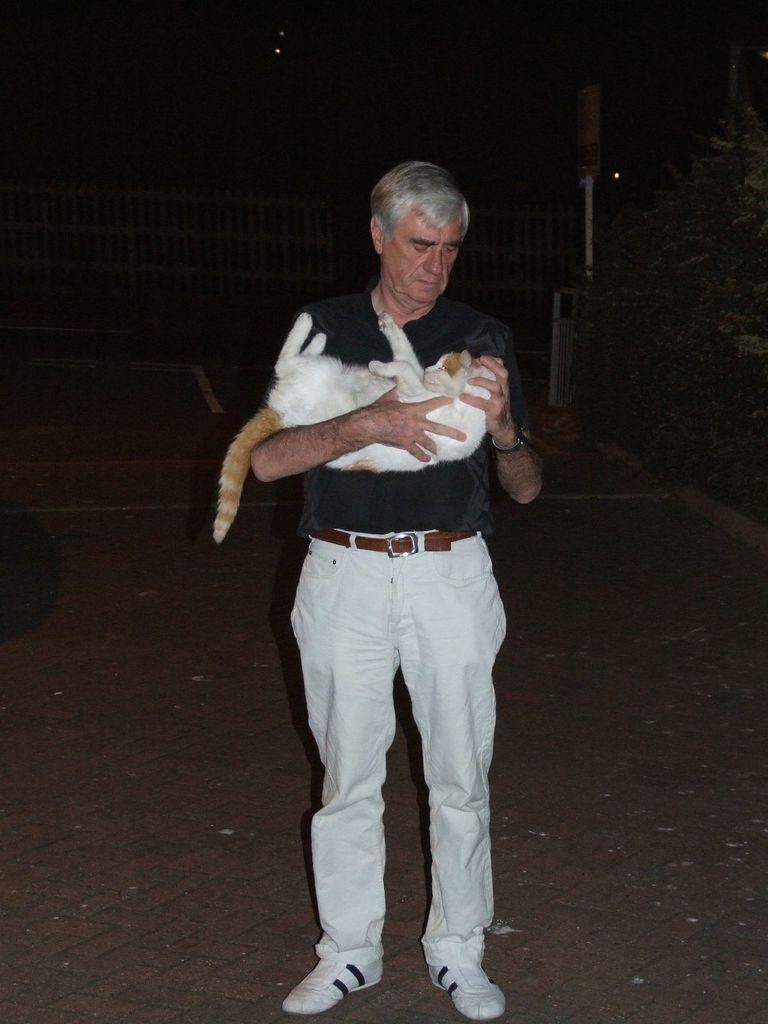What is the man in the image doing? The man is standing in the image and holding a cat. What else can be seen in the image besides the man and the cat? There are plants visible in the image. How would you describe the overall lighting in the image? The background of the image is dark. What type of pot is the man attempting to use to catch the cat's face in the image? There is no pot or attempt to catch the cat's face present in the image. 